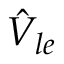<formula> <loc_0><loc_0><loc_500><loc_500>\hat { V } _ { l e }</formula> 